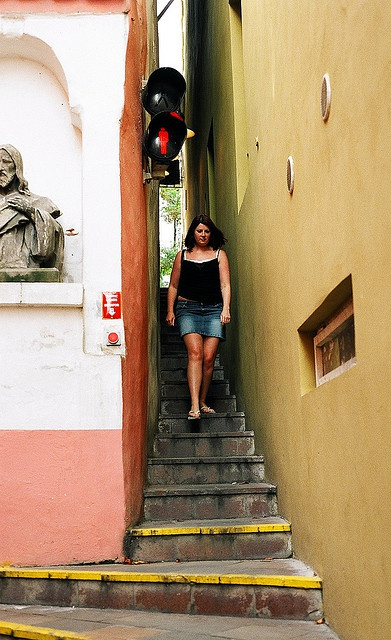Describe the objects in this image and their specific colors. I can see people in salmon, black, maroon, brown, and tan tones and traffic light in salmon, black, red, gray, and white tones in this image. 